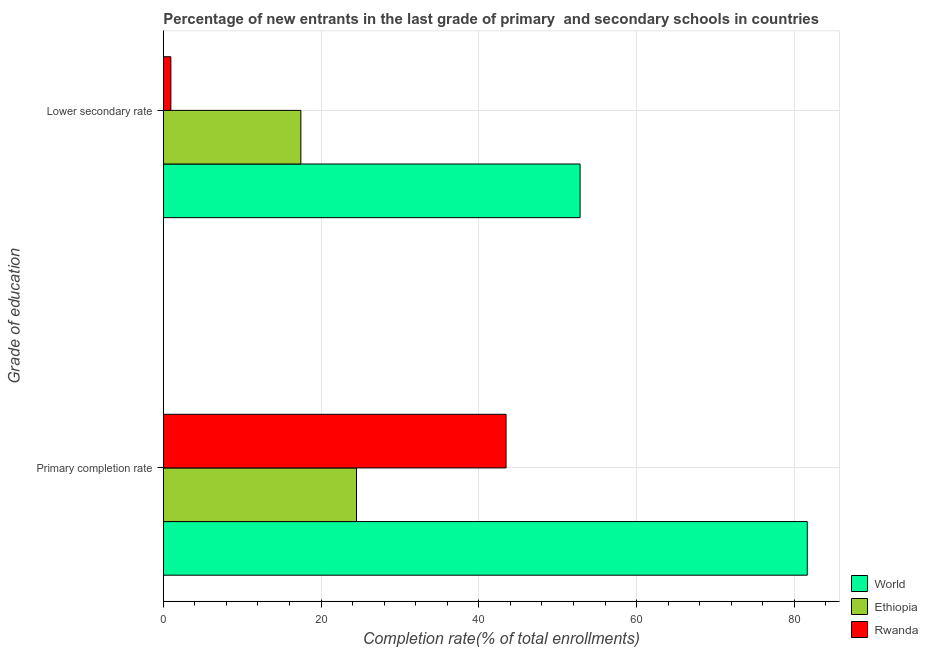How many different coloured bars are there?
Keep it short and to the point. 3. Are the number of bars per tick equal to the number of legend labels?
Your response must be concise. Yes. Are the number of bars on each tick of the Y-axis equal?
Offer a very short reply. Yes. How many bars are there on the 2nd tick from the bottom?
Give a very brief answer. 3. What is the label of the 1st group of bars from the top?
Keep it short and to the point. Lower secondary rate. What is the completion rate in primary schools in World?
Offer a terse response. 81.64. Across all countries, what is the maximum completion rate in primary schools?
Provide a succinct answer. 81.64. Across all countries, what is the minimum completion rate in primary schools?
Provide a short and direct response. 24.5. In which country was the completion rate in secondary schools minimum?
Your response must be concise. Rwanda. What is the total completion rate in primary schools in the graph?
Make the answer very short. 149.6. What is the difference between the completion rate in secondary schools in Rwanda and that in World?
Your response must be concise. -51.88. What is the difference between the completion rate in primary schools in Rwanda and the completion rate in secondary schools in Ethiopia?
Offer a very short reply. 26.01. What is the average completion rate in primary schools per country?
Your response must be concise. 49.87. What is the difference between the completion rate in primary schools and completion rate in secondary schools in Ethiopia?
Keep it short and to the point. 7.05. In how many countries, is the completion rate in primary schools greater than 20 %?
Keep it short and to the point. 3. What is the ratio of the completion rate in secondary schools in Ethiopia to that in World?
Make the answer very short. 0.33. Is the completion rate in primary schools in World less than that in Rwanda?
Give a very brief answer. No. In how many countries, is the completion rate in primary schools greater than the average completion rate in primary schools taken over all countries?
Provide a short and direct response. 1. What does the 3rd bar from the top in Primary completion rate represents?
Provide a short and direct response. World. What does the 3rd bar from the bottom in Primary completion rate represents?
Provide a succinct answer. Rwanda. How many bars are there?
Your response must be concise. 6. How many countries are there in the graph?
Offer a very short reply. 3. What is the difference between two consecutive major ticks on the X-axis?
Your response must be concise. 20. Are the values on the major ticks of X-axis written in scientific E-notation?
Provide a succinct answer. No. Does the graph contain any zero values?
Keep it short and to the point. No. Where does the legend appear in the graph?
Offer a very short reply. Bottom right. How many legend labels are there?
Provide a short and direct response. 3. How are the legend labels stacked?
Offer a terse response. Vertical. What is the title of the graph?
Your response must be concise. Percentage of new entrants in the last grade of primary  and secondary schools in countries. Does "Aruba" appear as one of the legend labels in the graph?
Your answer should be compact. No. What is the label or title of the X-axis?
Your answer should be very brief. Completion rate(% of total enrollments). What is the label or title of the Y-axis?
Offer a terse response. Grade of education. What is the Completion rate(% of total enrollments) of World in Primary completion rate?
Ensure brevity in your answer.  81.64. What is the Completion rate(% of total enrollments) of Ethiopia in Primary completion rate?
Provide a short and direct response. 24.5. What is the Completion rate(% of total enrollments) of Rwanda in Primary completion rate?
Ensure brevity in your answer.  43.46. What is the Completion rate(% of total enrollments) in World in Lower secondary rate?
Provide a short and direct response. 52.84. What is the Completion rate(% of total enrollments) in Ethiopia in Lower secondary rate?
Your answer should be compact. 17.44. What is the Completion rate(% of total enrollments) in Rwanda in Lower secondary rate?
Your response must be concise. 0.96. Across all Grade of education, what is the maximum Completion rate(% of total enrollments) of World?
Keep it short and to the point. 81.64. Across all Grade of education, what is the maximum Completion rate(% of total enrollments) in Ethiopia?
Keep it short and to the point. 24.5. Across all Grade of education, what is the maximum Completion rate(% of total enrollments) of Rwanda?
Your answer should be compact. 43.46. Across all Grade of education, what is the minimum Completion rate(% of total enrollments) of World?
Offer a terse response. 52.84. Across all Grade of education, what is the minimum Completion rate(% of total enrollments) of Ethiopia?
Give a very brief answer. 17.44. Across all Grade of education, what is the minimum Completion rate(% of total enrollments) in Rwanda?
Provide a short and direct response. 0.96. What is the total Completion rate(% of total enrollments) of World in the graph?
Ensure brevity in your answer.  134.48. What is the total Completion rate(% of total enrollments) in Ethiopia in the graph?
Make the answer very short. 41.94. What is the total Completion rate(% of total enrollments) of Rwanda in the graph?
Your answer should be compact. 44.42. What is the difference between the Completion rate(% of total enrollments) in World in Primary completion rate and that in Lower secondary rate?
Offer a very short reply. 28.8. What is the difference between the Completion rate(% of total enrollments) in Ethiopia in Primary completion rate and that in Lower secondary rate?
Make the answer very short. 7.05. What is the difference between the Completion rate(% of total enrollments) in Rwanda in Primary completion rate and that in Lower secondary rate?
Ensure brevity in your answer.  42.5. What is the difference between the Completion rate(% of total enrollments) in World in Primary completion rate and the Completion rate(% of total enrollments) in Ethiopia in Lower secondary rate?
Offer a very short reply. 64.2. What is the difference between the Completion rate(% of total enrollments) in World in Primary completion rate and the Completion rate(% of total enrollments) in Rwanda in Lower secondary rate?
Make the answer very short. 80.68. What is the difference between the Completion rate(% of total enrollments) in Ethiopia in Primary completion rate and the Completion rate(% of total enrollments) in Rwanda in Lower secondary rate?
Offer a very short reply. 23.53. What is the average Completion rate(% of total enrollments) in World per Grade of education?
Your answer should be very brief. 67.24. What is the average Completion rate(% of total enrollments) in Ethiopia per Grade of education?
Ensure brevity in your answer.  20.97. What is the average Completion rate(% of total enrollments) of Rwanda per Grade of education?
Provide a succinct answer. 22.21. What is the difference between the Completion rate(% of total enrollments) of World and Completion rate(% of total enrollments) of Ethiopia in Primary completion rate?
Your answer should be very brief. 57.15. What is the difference between the Completion rate(% of total enrollments) of World and Completion rate(% of total enrollments) of Rwanda in Primary completion rate?
Provide a short and direct response. 38.19. What is the difference between the Completion rate(% of total enrollments) of Ethiopia and Completion rate(% of total enrollments) of Rwanda in Primary completion rate?
Keep it short and to the point. -18.96. What is the difference between the Completion rate(% of total enrollments) of World and Completion rate(% of total enrollments) of Ethiopia in Lower secondary rate?
Ensure brevity in your answer.  35.4. What is the difference between the Completion rate(% of total enrollments) of World and Completion rate(% of total enrollments) of Rwanda in Lower secondary rate?
Ensure brevity in your answer.  51.88. What is the difference between the Completion rate(% of total enrollments) of Ethiopia and Completion rate(% of total enrollments) of Rwanda in Lower secondary rate?
Offer a terse response. 16.48. What is the ratio of the Completion rate(% of total enrollments) of World in Primary completion rate to that in Lower secondary rate?
Keep it short and to the point. 1.55. What is the ratio of the Completion rate(% of total enrollments) in Ethiopia in Primary completion rate to that in Lower secondary rate?
Ensure brevity in your answer.  1.4. What is the ratio of the Completion rate(% of total enrollments) in Rwanda in Primary completion rate to that in Lower secondary rate?
Your response must be concise. 45.17. What is the difference between the highest and the second highest Completion rate(% of total enrollments) of World?
Offer a very short reply. 28.8. What is the difference between the highest and the second highest Completion rate(% of total enrollments) of Ethiopia?
Make the answer very short. 7.05. What is the difference between the highest and the second highest Completion rate(% of total enrollments) of Rwanda?
Keep it short and to the point. 42.5. What is the difference between the highest and the lowest Completion rate(% of total enrollments) of World?
Ensure brevity in your answer.  28.8. What is the difference between the highest and the lowest Completion rate(% of total enrollments) of Ethiopia?
Offer a terse response. 7.05. What is the difference between the highest and the lowest Completion rate(% of total enrollments) in Rwanda?
Offer a very short reply. 42.5. 